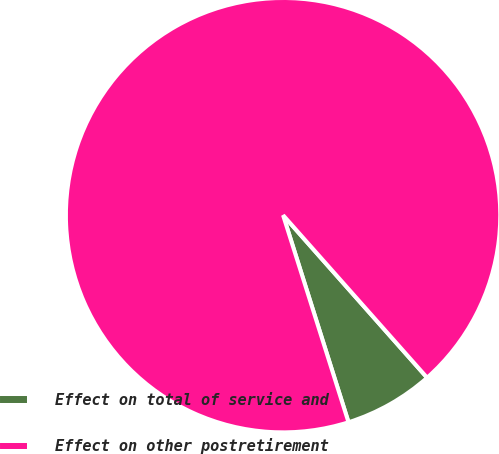<chart> <loc_0><loc_0><loc_500><loc_500><pie_chart><fcel>Effect on total of service and<fcel>Effect on other postretirement<nl><fcel>6.67%<fcel>93.33%<nl></chart> 